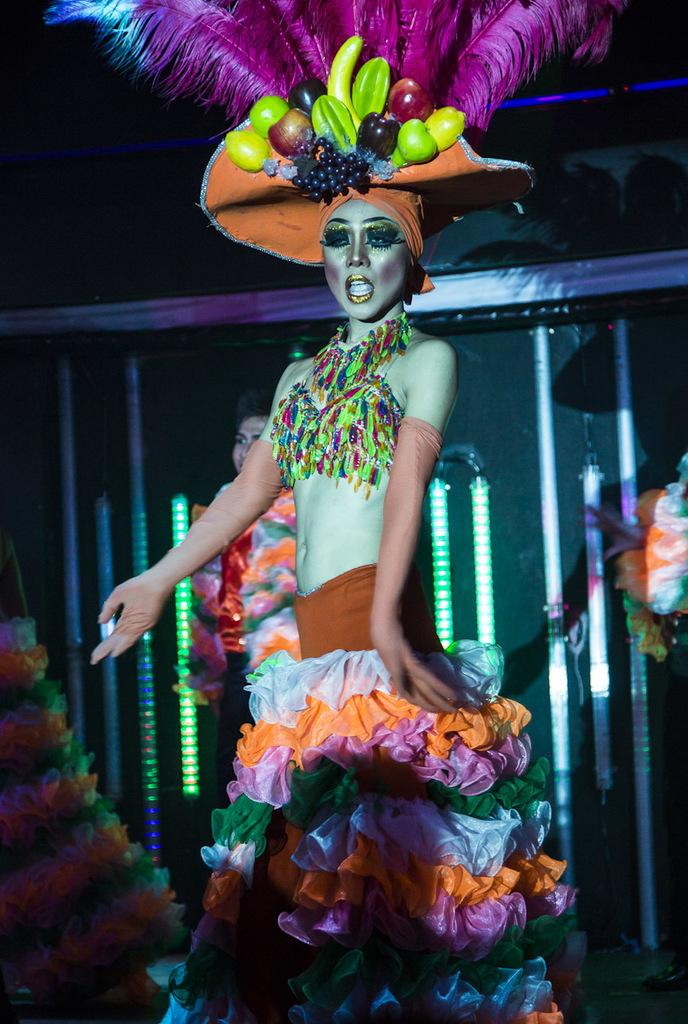Who is the main subject in the image? There is a lady in the center of the image. What is the lady doing in the image? The lady is standing. What accessory is the lady wearing in the image? The lady is wearing a hat. What can be seen in the background of the image? There is a wall and lights in the background of the image. How does the lady twist her bones in the image? There is no indication in the image that the lady is twisting her bones in the image. 